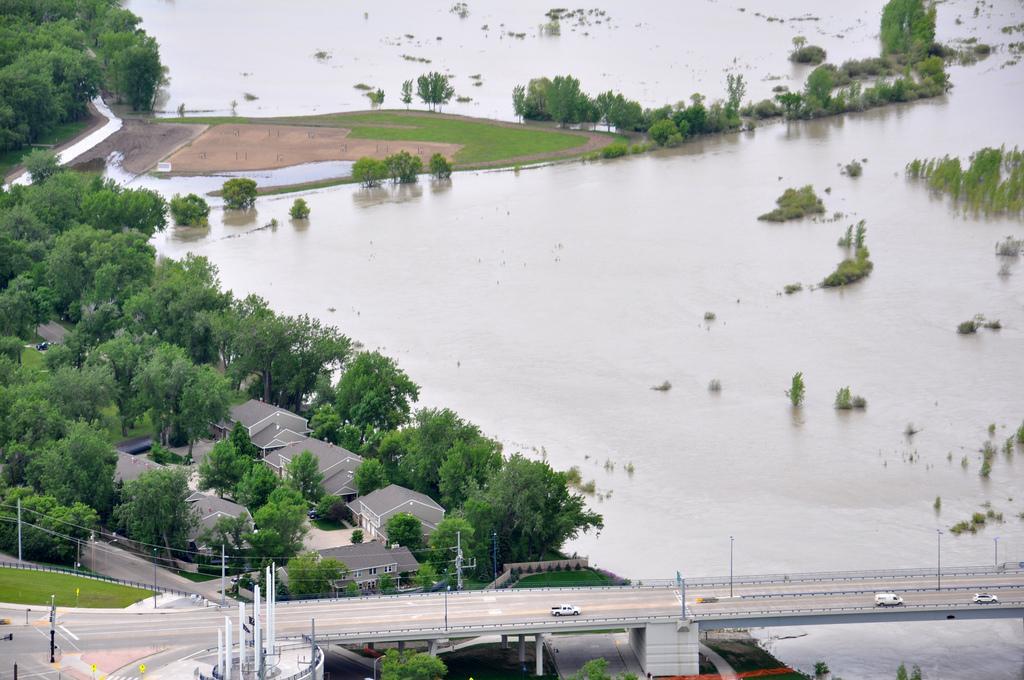Please provide a concise description of this image. This is an aerial view of an image where we can see vehicles are moving on the bridge, we can see trees and houses on the left side of the image and we can see water and grassland on the right side of the image. 